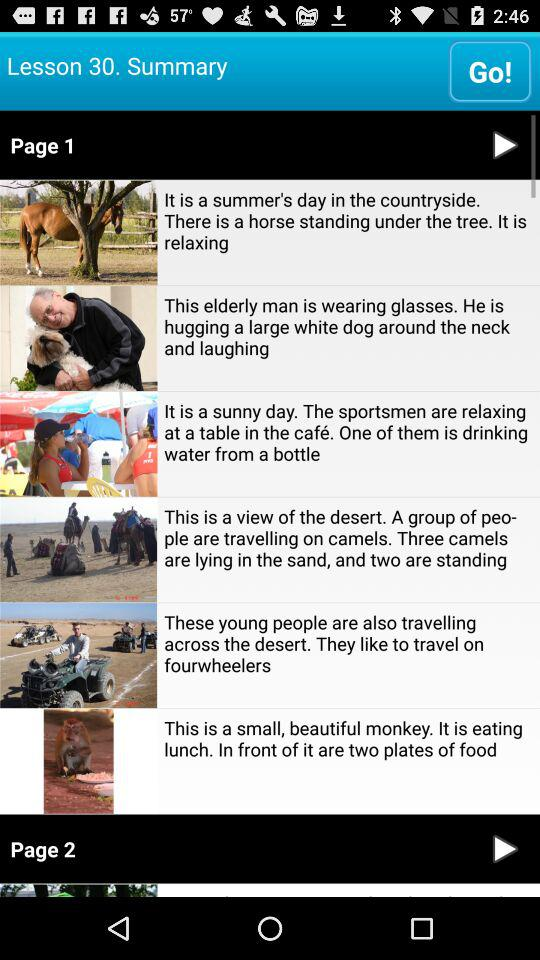What is the page number? The page numbers are 1 and 2. 